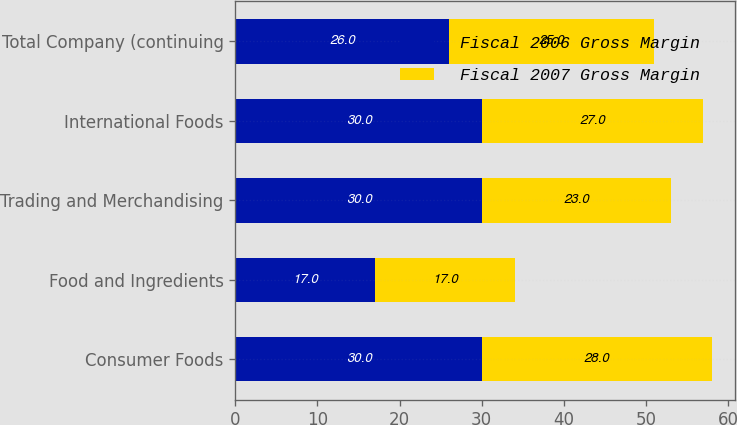Convert chart. <chart><loc_0><loc_0><loc_500><loc_500><stacked_bar_chart><ecel><fcel>Consumer Foods<fcel>Food and Ingredients<fcel>Trading and Merchandising<fcel>International Foods<fcel>Total Company (continuing<nl><fcel>Fiscal 2006 Gross Margin<fcel>30<fcel>17<fcel>30<fcel>30<fcel>26<nl><fcel>Fiscal 2007 Gross Margin<fcel>28<fcel>17<fcel>23<fcel>27<fcel>25<nl></chart> 